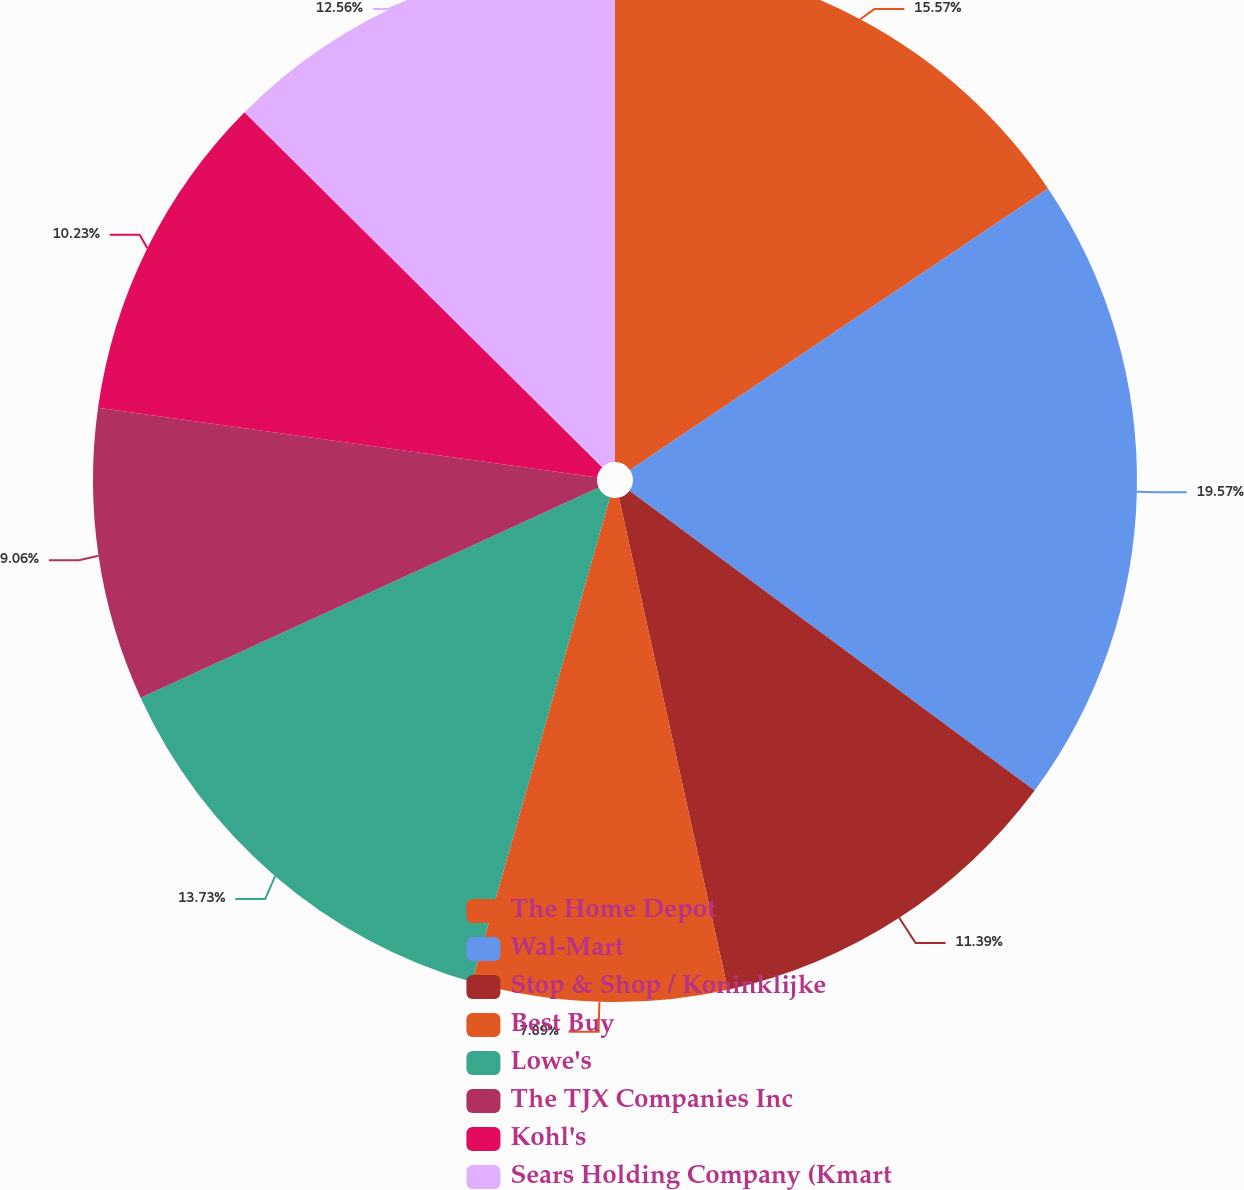Convert chart. <chart><loc_0><loc_0><loc_500><loc_500><pie_chart><fcel>The Home Depot<fcel>Wal-Mart<fcel>Stop & Shop / Koninklijke<fcel>Best Buy<fcel>Lowe's<fcel>The TJX Companies Inc<fcel>Kohl's<fcel>Sears Holding Company (Kmart<nl><fcel>15.57%<fcel>19.57%<fcel>11.39%<fcel>7.89%<fcel>13.73%<fcel>9.06%<fcel>10.23%<fcel>12.56%<nl></chart> 